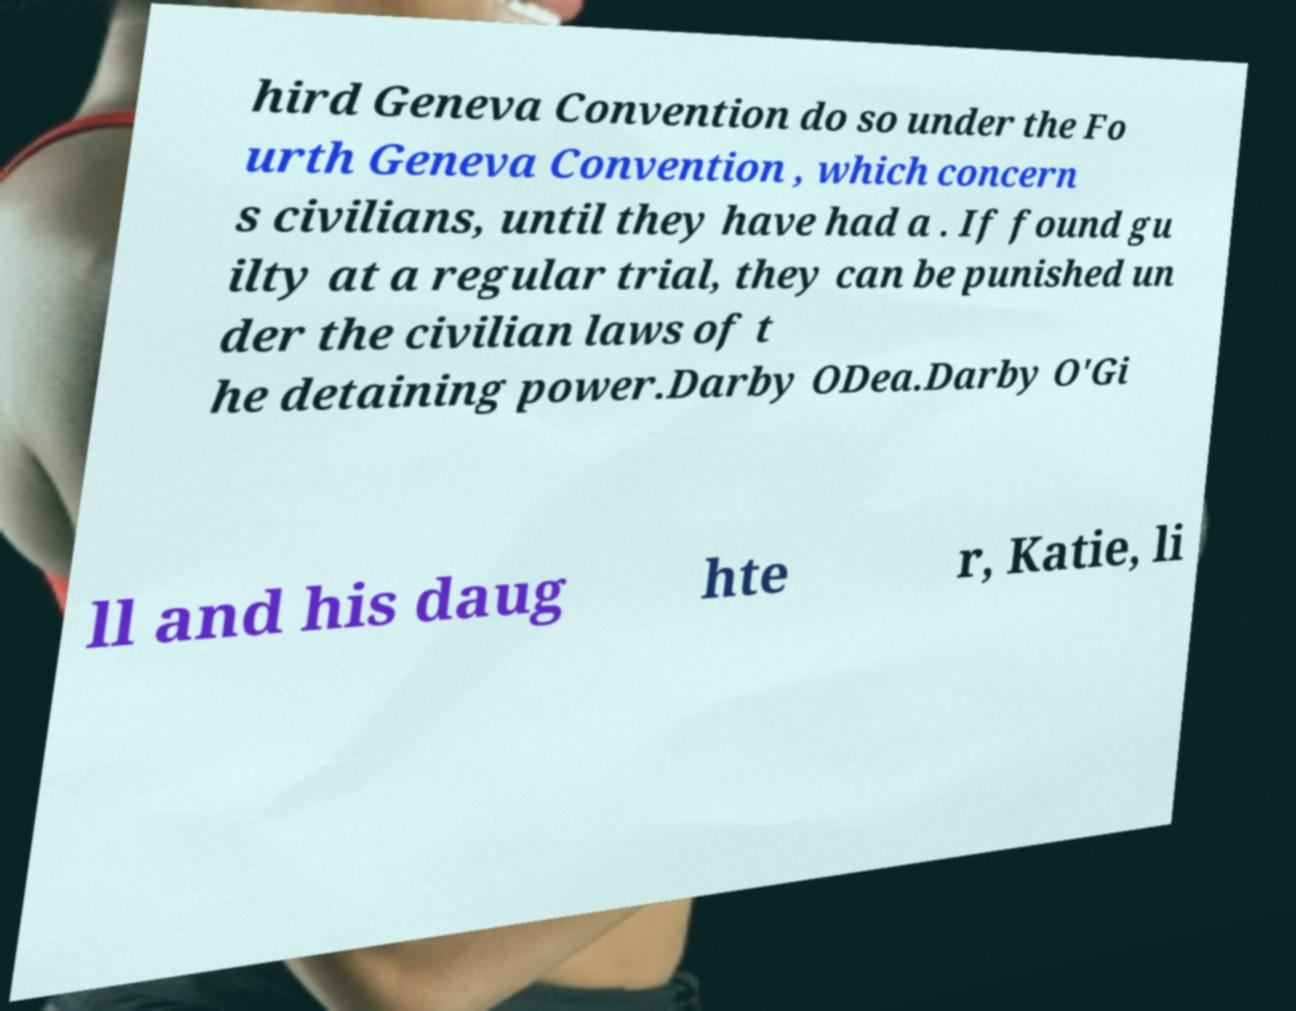Please identify and transcribe the text found in this image. hird Geneva Convention do so under the Fo urth Geneva Convention , which concern s civilians, until they have had a . If found gu ilty at a regular trial, they can be punished un der the civilian laws of t he detaining power.Darby ODea.Darby O'Gi ll and his daug hte r, Katie, li 